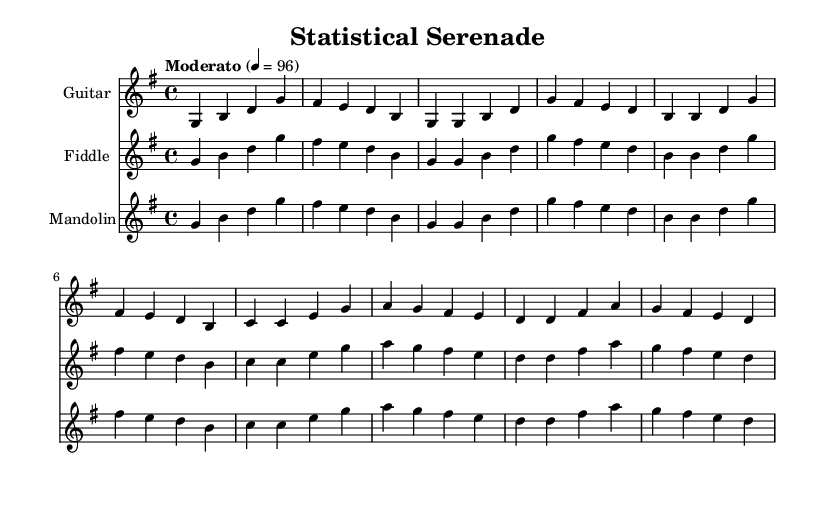What is the key signature of this music? The key signature is G major, which has one sharp (F#). It can be identified by examining the key signature at the beginning of the staff lines.
Answer: G major What is the time signature of this music? The time signature is 4/4, indicated at the beginning of the score with two numbers, where the top number shows four beats per measure and the bottom number indicates that the quarter note gets one beat.
Answer: 4/4 What is the tempo marking provided for this piece? The tempo marking is "Moderato" set at a quarter note value of 96 beats per minute. This is observable in the tempo notation at the beginning of the music sheet.
Answer: Moderato 4 = 96 How many measures are in the score? The score contains 8 measures, identified by counting the groups of notes separated by the vertical lines (bar lines) in each staff.
Answer: 8 Which instruments are featured in this piece? The instruments featured are Guitar, Fiddle, and Mandolin. This can be found in the staff names and the notation at the beginning of each instrument’s part.
Answer: Guitar, Fiddle, Mandolin What melodic pattern is repeated in the piece? The melodic pattern that is repeated is the sequence of notes starting from G in each instrument. Analyzing the notes played reveals that the same rhythmic and pitch combinations recur throughout the score.
Answer: G B D G What is the final note in each instrument's part? The final note in each instrument's part is D. This can be determined by looking at the last note shown in each individual staff, indicating the conclusion of each part.
Answer: D 